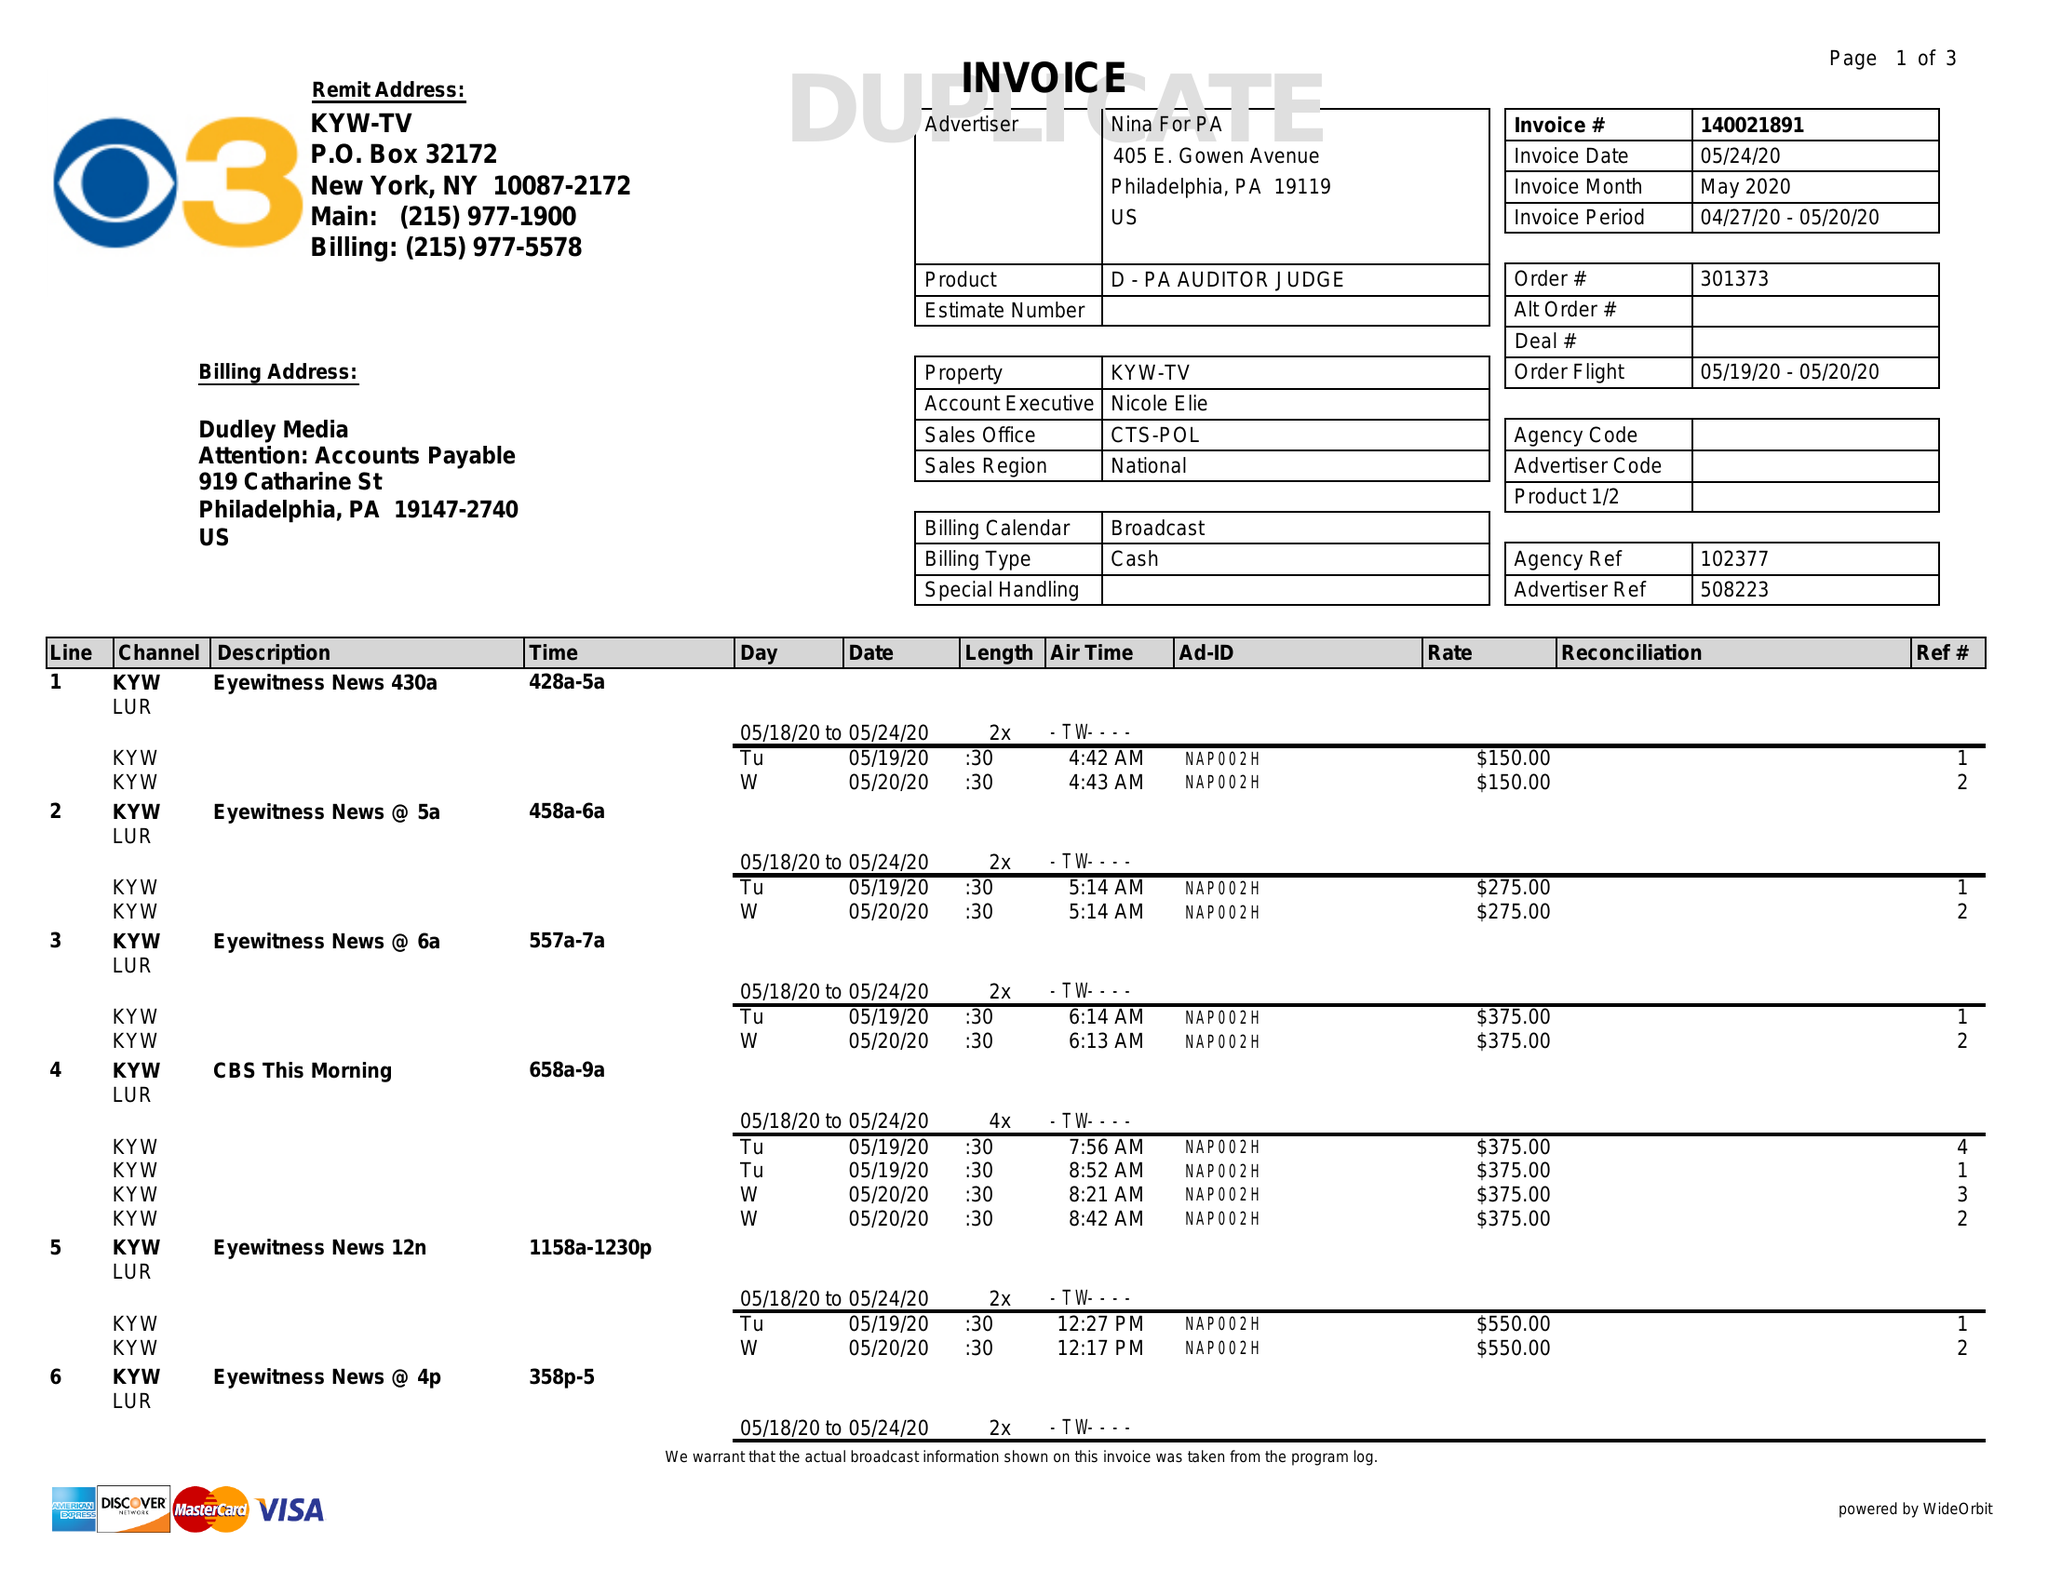What is the value for the flight_from?
Answer the question using a single word or phrase. 05/19/20 